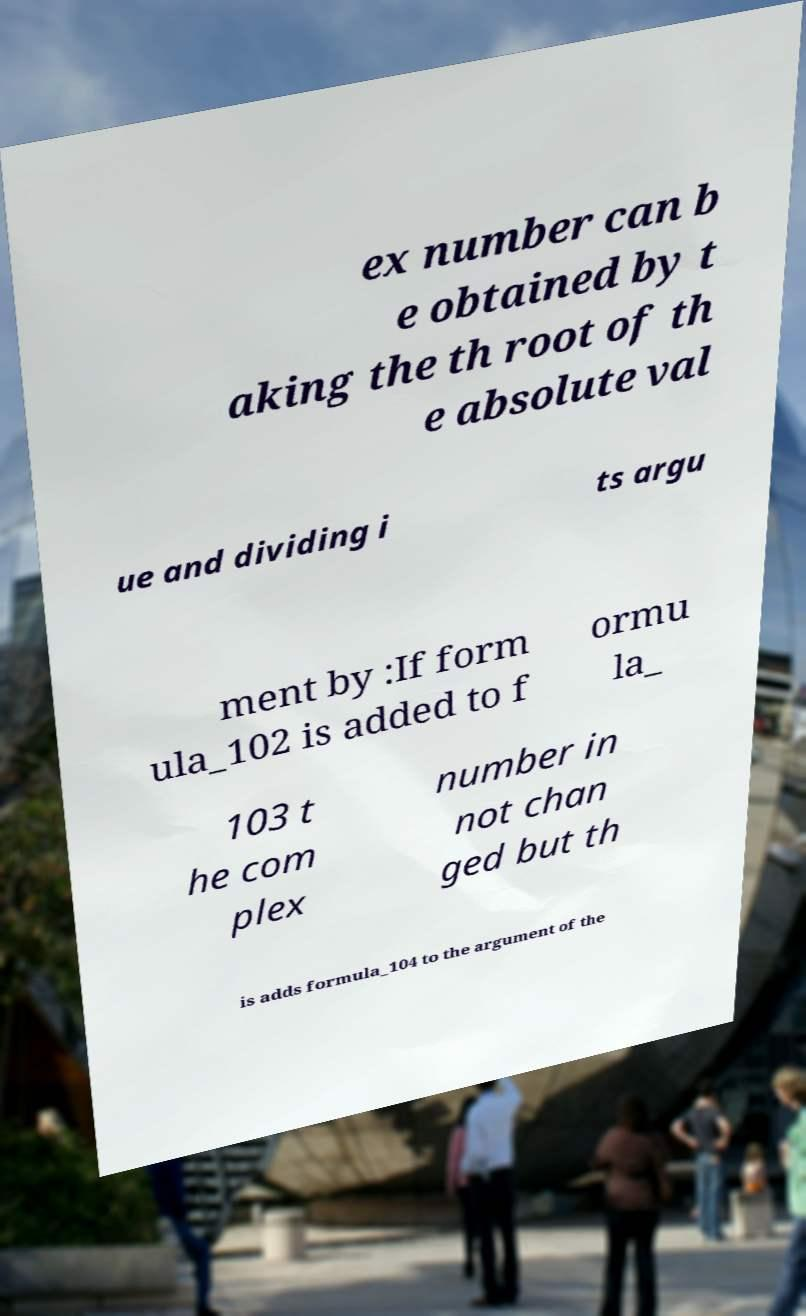Could you extract and type out the text from this image? ex number can b e obtained by t aking the th root of th e absolute val ue and dividing i ts argu ment by :If form ula_102 is added to f ormu la_ 103 t he com plex number in not chan ged but th is adds formula_104 to the argument of the 